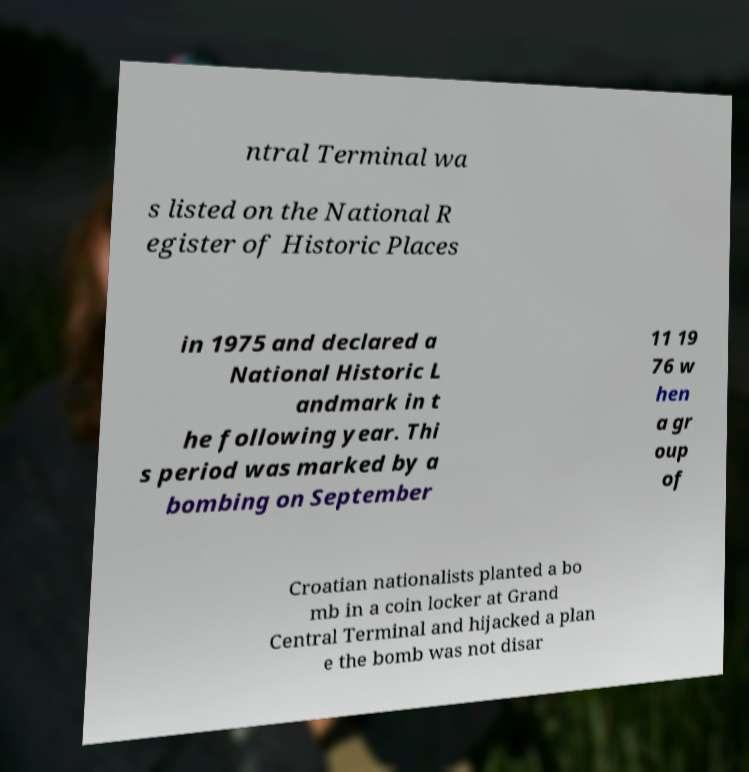For documentation purposes, I need the text within this image transcribed. Could you provide that? ntral Terminal wa s listed on the National R egister of Historic Places in 1975 and declared a National Historic L andmark in t he following year. Thi s period was marked by a bombing on September 11 19 76 w hen a gr oup of Croatian nationalists planted a bo mb in a coin locker at Grand Central Terminal and hijacked a plan e the bomb was not disar 